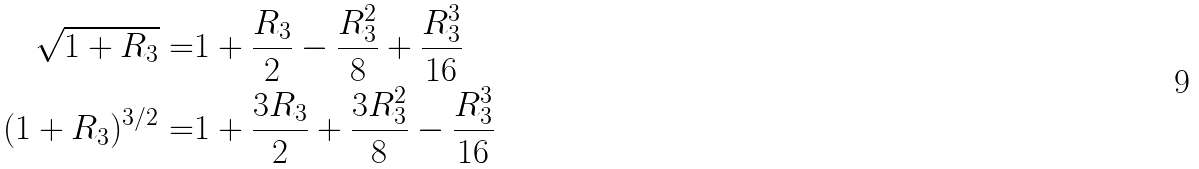Convert formula to latex. <formula><loc_0><loc_0><loc_500><loc_500>\sqrt { 1 + R _ { 3 } } = & 1 + \frac { R _ { 3 } } { 2 } - \frac { R _ { 3 } ^ { 2 } } { 8 } + \frac { R _ { 3 } ^ { 3 } } { 1 6 } \\ ( 1 + R _ { 3 } ) ^ { 3 / 2 } = & 1 + \frac { 3 R _ { 3 } } { 2 } + \frac { 3 R _ { 3 } ^ { 2 } } { 8 } - \frac { R _ { 3 } ^ { 3 } } { 1 6 }</formula> 